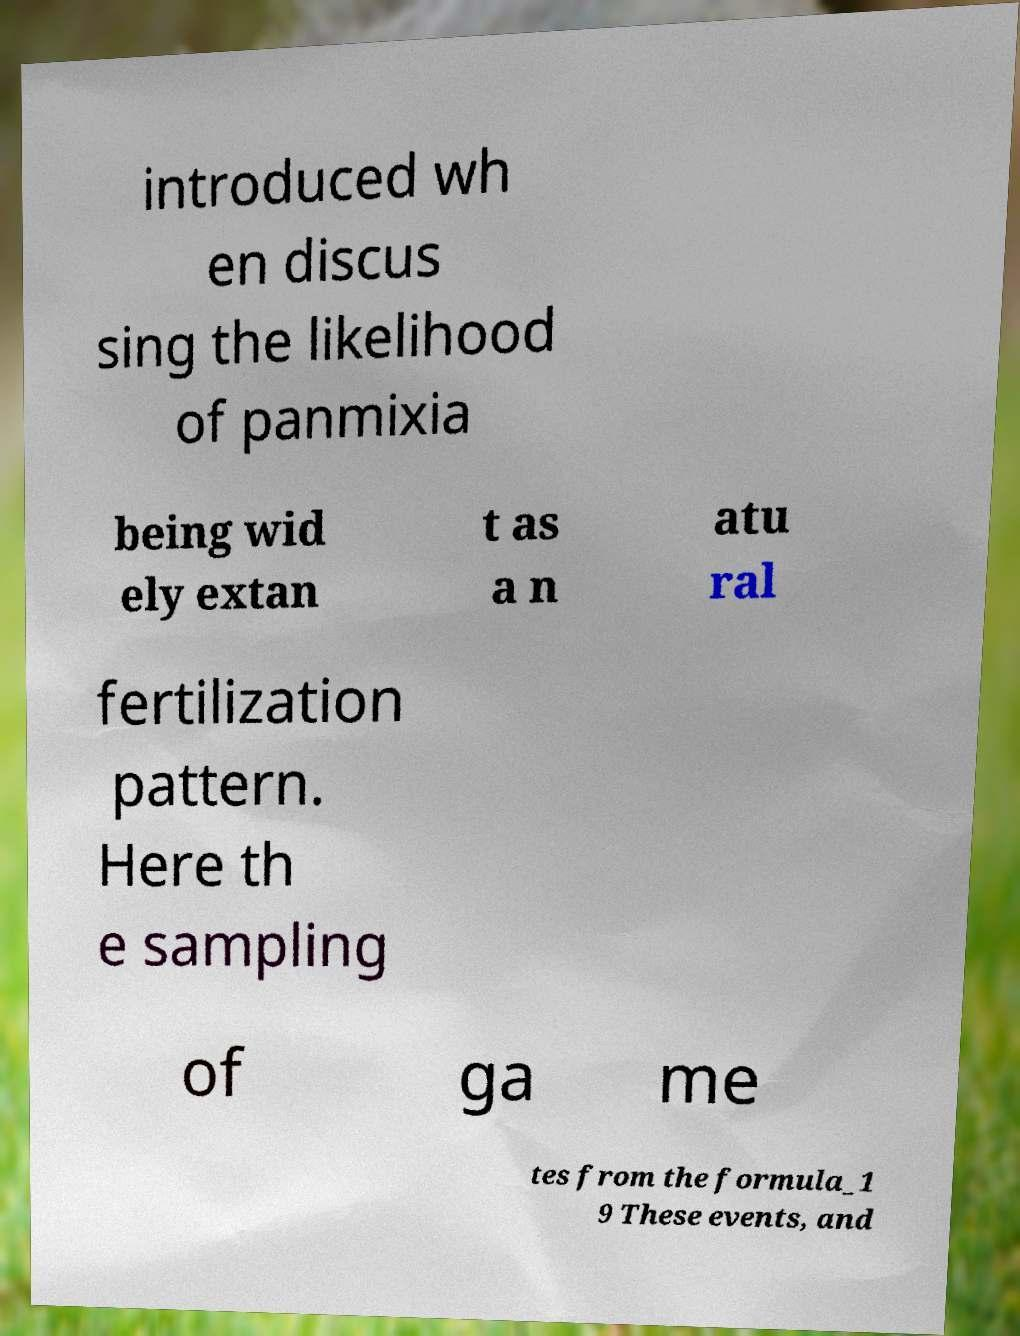Could you extract and type out the text from this image? introduced wh en discus sing the likelihood of panmixia being wid ely extan t as a n atu ral fertilization pattern. Here th e sampling of ga me tes from the formula_1 9 These events, and 